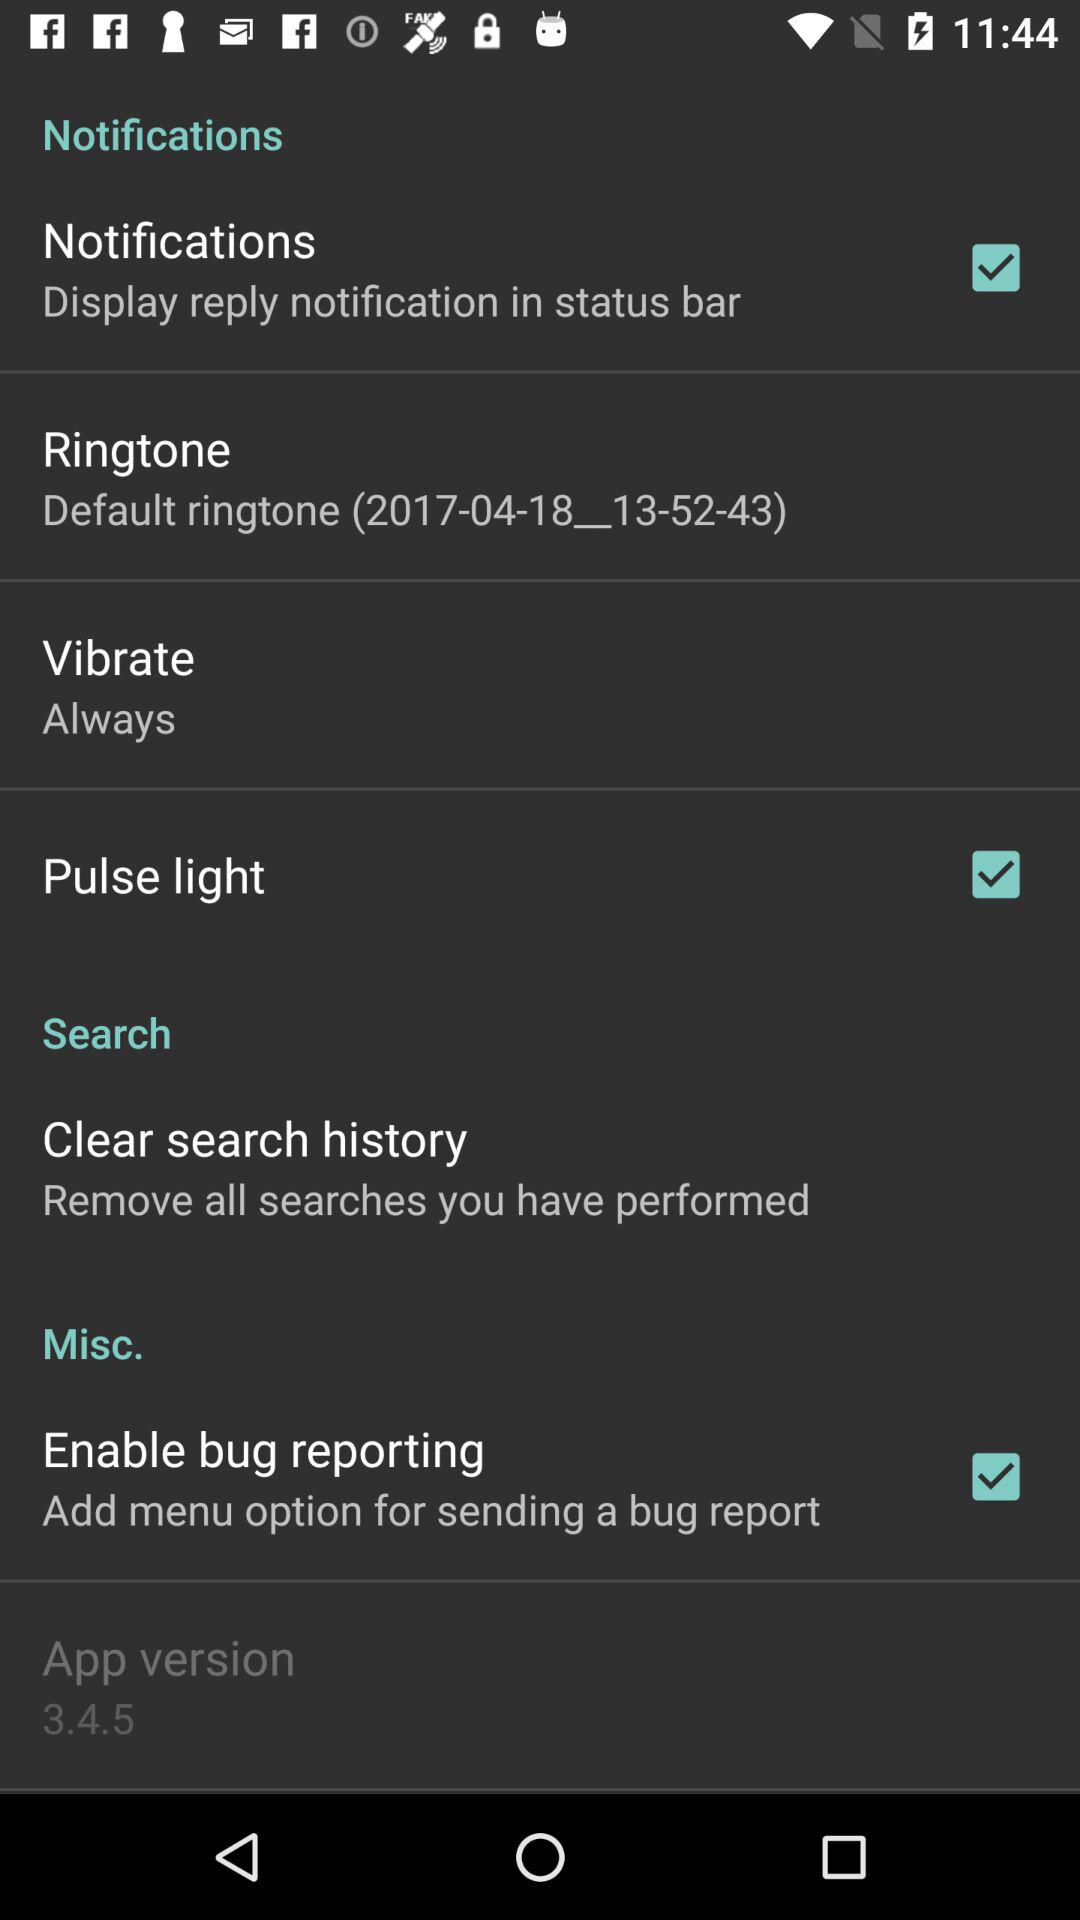What is the application version? The application version is 3.4.5. 